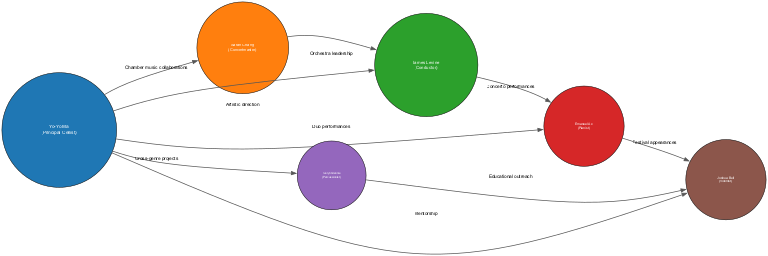What is the role of the node labeled "Yo-Yo Ma"? According to the diagram, the label associated with the node "Yo-Yo Ma" indicates that he is the "Principal Cellist."
Answer: Principal Cellist How many nodes are displayed in the diagram? By counting each labeled node in the diagram, we find there are a total of six distinct nodes representing different roles.
Answer: 6 What is the relationship between "Yo-Yo Ma" and "James Levine"? From the edges in the diagram, the relationship between "Yo-Yo Ma" and "James Levine" is characterized by "Artistic direction."
Answer: Artistic direction Which musician collaborates with "Yo-Yo Ma" for "Duo performances"? The edge connecting "Yo-Yo Ma" with another node specifies that "Emanuel Ax" is involved in "Duo performances" with him.
Answer: Emanuel Ax Who is the Concertmaster in the orchestra? The labeled node in the diagram shows that "Sarah Chang" holds the position of Concertmaster.
Answer: Sarah Chang Which two musicians are directly connected through "Educational outreach"? The diagram clearly indicates that "Evelyn Glennie" and "Joshua Bell" have a direct edge labeled "Educational outreach" connecting them.
Answer: Evelyn Glennie and Joshua Bell What is the minimum size among the musicians in the diagram? The smallest node size, as indicated in the diagram data, corresponds to "Evelyn Glennie," who has a size of 60, making her the one with the minimum size.
Answer: 60 How many edges connect to "Yo-Yo Ma"? By inspecting the connections, we find that "Yo-Yo Ma" has five edges connecting him to other musicians, indicating multiple relationships.
Answer: 5 Which role has the highest size value in the diagram? Analyzing the sizes of the roles, "Yo-Yo Ma," the Principal Cellist, has the highest size value of 100, making his role the most prominent.
Answer: Principal Cellist 